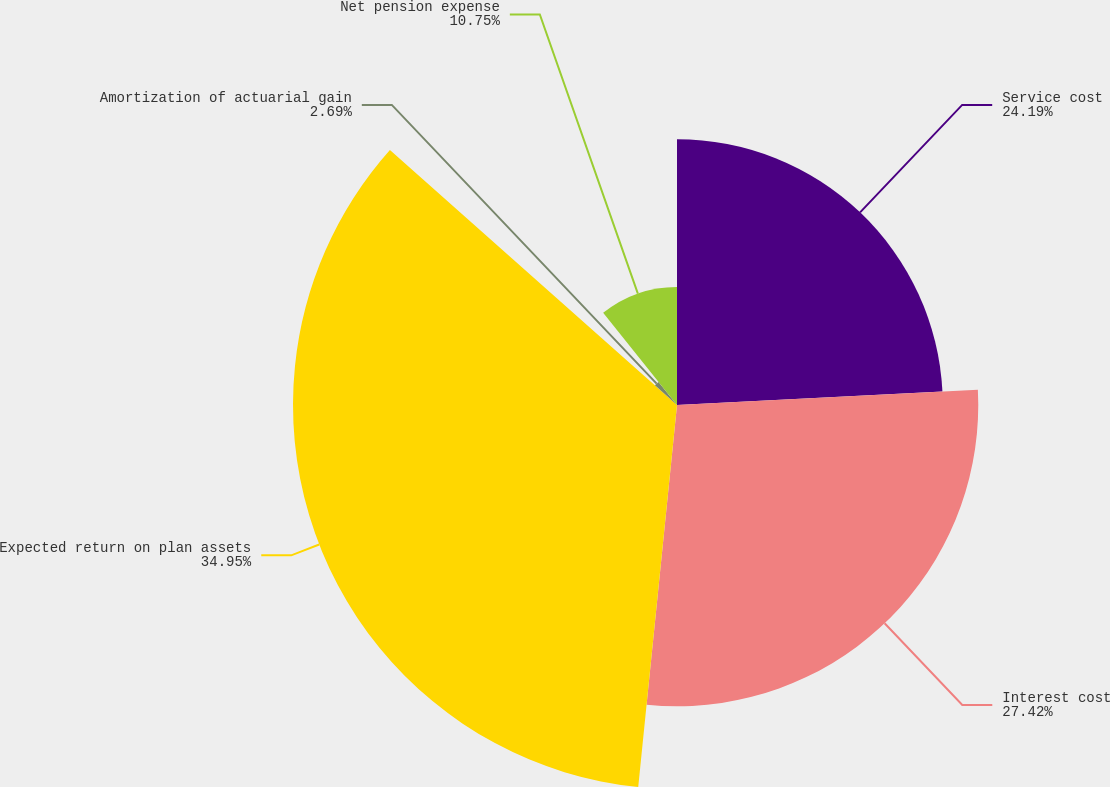Convert chart. <chart><loc_0><loc_0><loc_500><loc_500><pie_chart><fcel>Service cost<fcel>Interest cost<fcel>Expected return on plan assets<fcel>Amortization of actuarial gain<fcel>Net pension expense<nl><fcel>24.19%<fcel>27.42%<fcel>34.95%<fcel>2.69%<fcel>10.75%<nl></chart> 